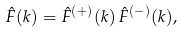Convert formula to latex. <formula><loc_0><loc_0><loc_500><loc_500>\hat { F } ( k ) = \hat { F } ^ { ( + ) } ( k ) \, \hat { F } ^ { ( - ) } ( k ) ,</formula> 